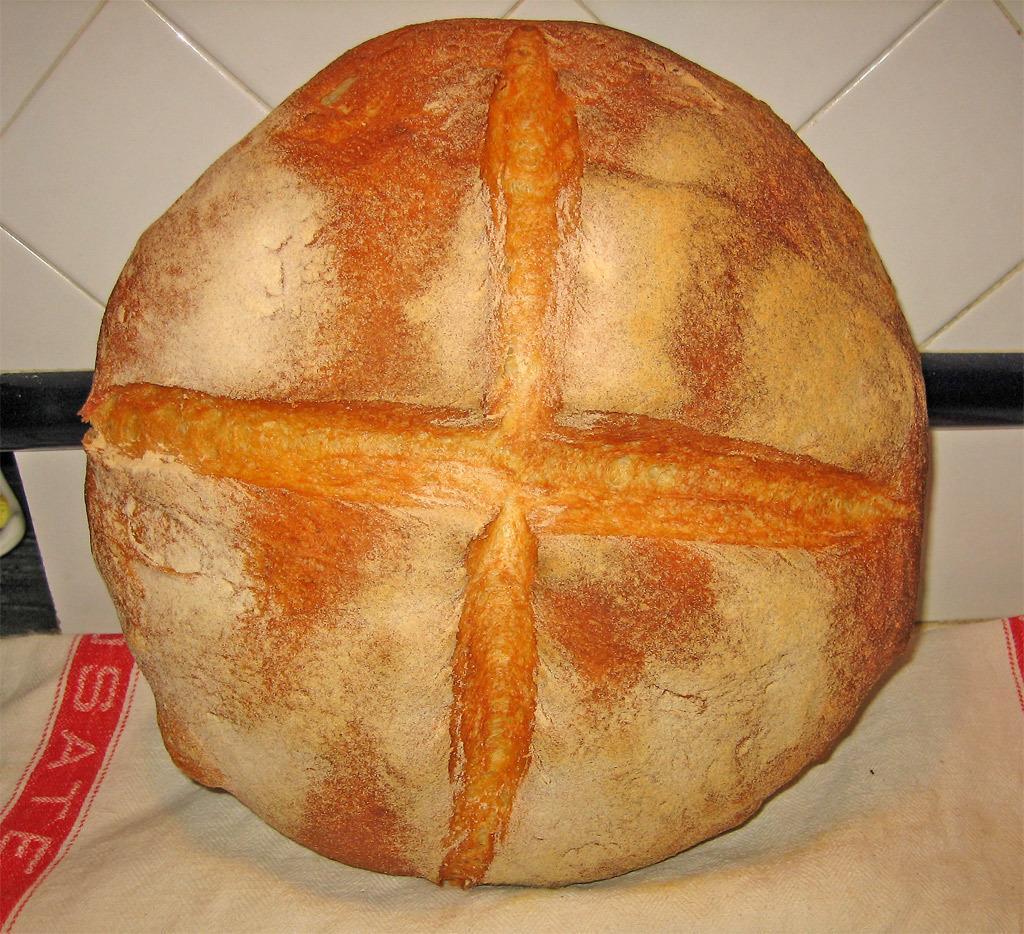In one or two sentences, can you explain what this image depicts? In this image, we can see an object on the cloth in front of the wall. 